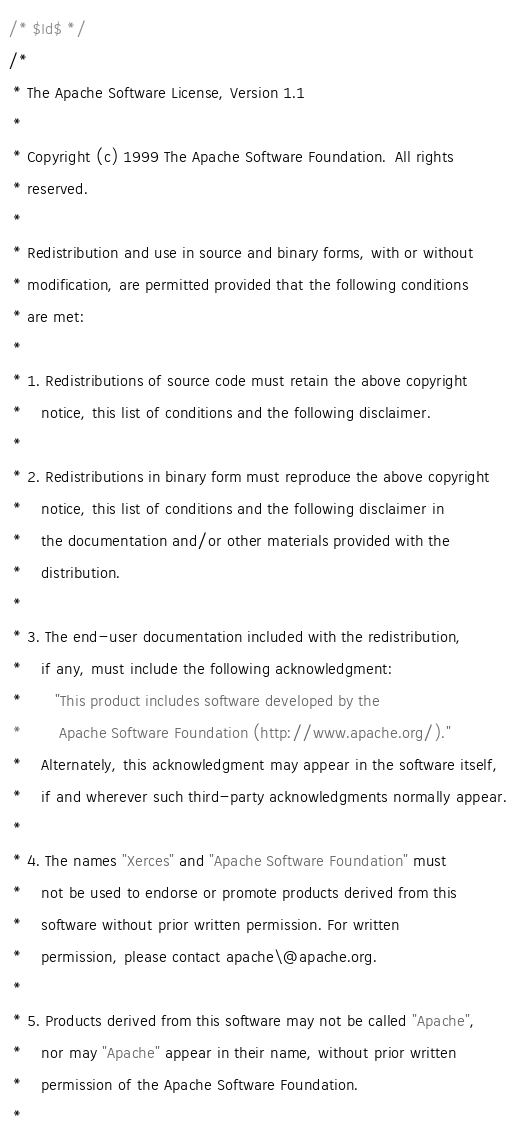<code> <loc_0><loc_0><loc_500><loc_500><_Java_>/* $Id$ */
/*
 * The Apache Software License, Version 1.1
 * 
 * Copyright (c) 1999 The Apache Software Foundation.  All rights 
 * reserved.
 * 
 * Redistribution and use in source and binary forms, with or without
 * modification, are permitted provided that the following conditions
 * are met:
 * 
 * 1. Redistributions of source code must retain the above copyright
 *    notice, this list of conditions and the following disclaimer. 
 * 
 * 2. Redistributions in binary form must reproduce the above copyright
 *    notice, this list of conditions and the following disclaimer in
 *    the documentation and/or other materials provided with the
 *    distribution.
 * 
 * 3. The end-user documentation included with the redistribution,
 *    if any, must include the following acknowledgment:  
 *       "This product includes software developed by the
 *        Apache Software Foundation (http://www.apache.org/)."
 *    Alternately, this acknowledgment may appear in the software itself,
 *    if and wherever such third-party acknowledgments normally appear.
 * 
 * 4. The names "Xerces" and "Apache Software Foundation" must
 *    not be used to endorse or promote products derived from this
 *    software without prior written permission. For written 
 *    permission, please contact apache\@apache.org.
 * 
 * 5. Products derived from this software may not be called "Apache",
 *    nor may "Apache" appear in their name, without prior written
 *    permission of the Apache Software Foundation.
 * </code> 